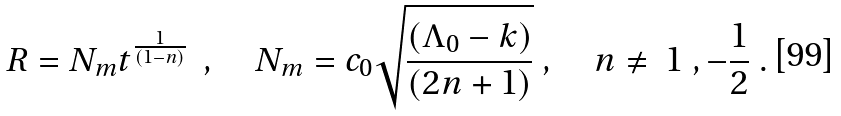<formula> <loc_0><loc_0><loc_500><loc_500>R = N _ { m } t ^ { \frac { 1 } { ( 1 - n ) } } \ \ , \quad N _ { m } = c _ { 0 } \sqrt { \frac { ( \Lambda _ { 0 } - k ) } { ( 2 n + 1 ) } } \ , \quad n \ne \ 1 \ , - \frac { 1 } { 2 } \ .</formula> 